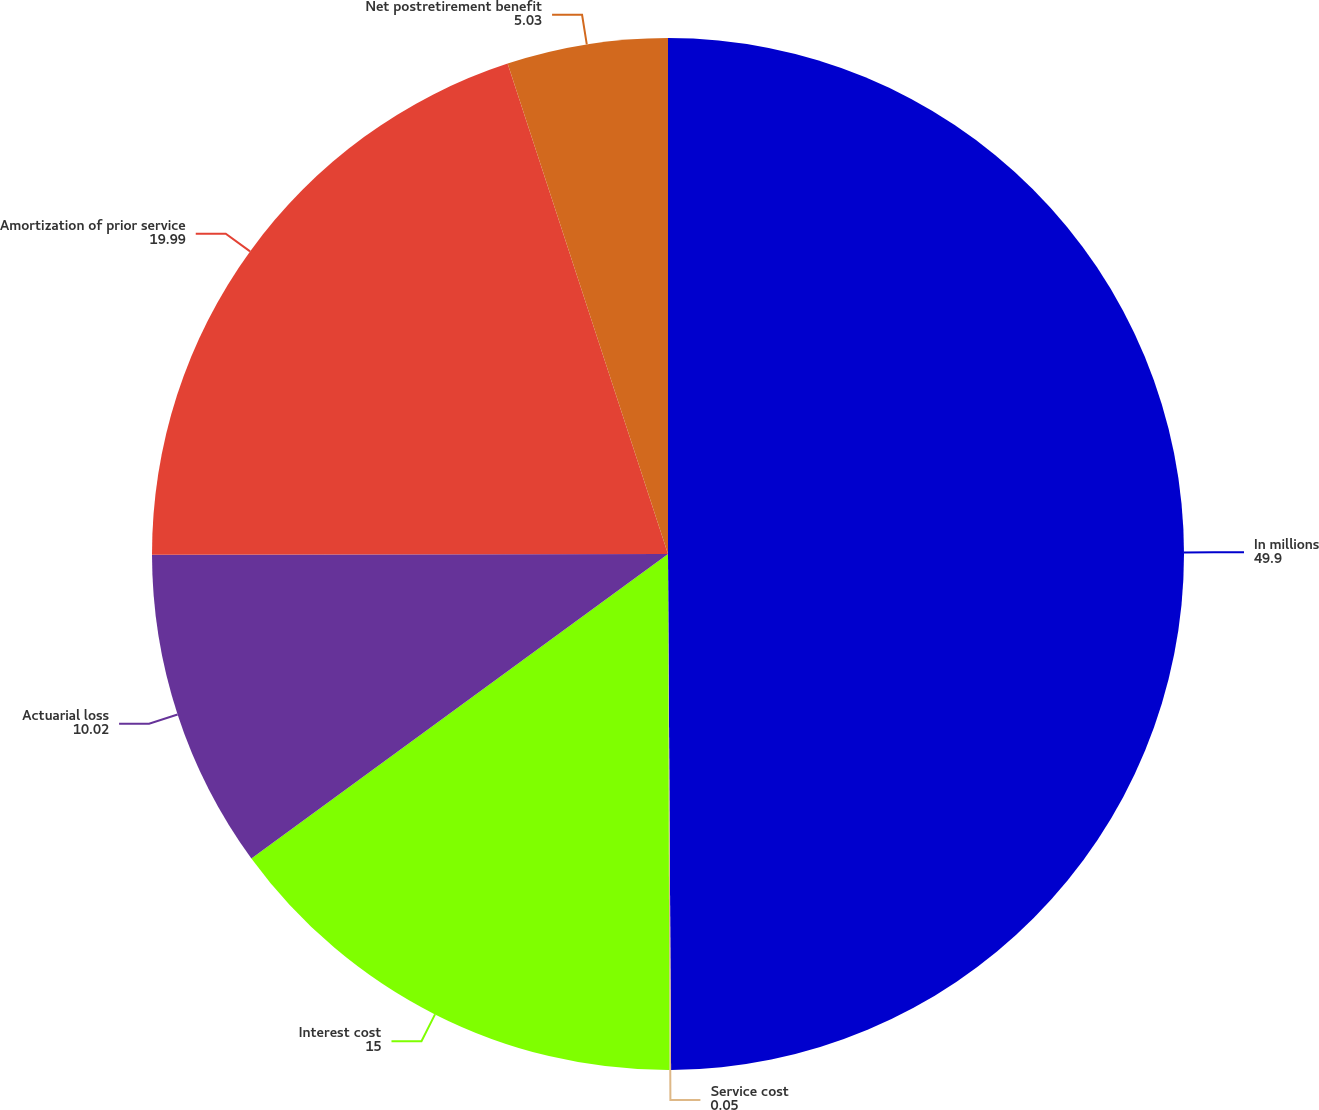Convert chart. <chart><loc_0><loc_0><loc_500><loc_500><pie_chart><fcel>In millions<fcel>Service cost<fcel>Interest cost<fcel>Actuarial loss<fcel>Amortization of prior service<fcel>Net postretirement benefit<nl><fcel>49.9%<fcel>0.05%<fcel>15.0%<fcel>10.02%<fcel>19.99%<fcel>5.03%<nl></chart> 